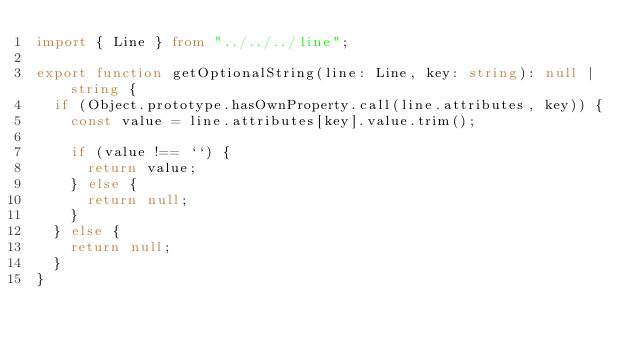<code> <loc_0><loc_0><loc_500><loc_500><_TypeScript_>import { Line } from "../../../line";

export function getOptionalString(line: Line, key: string): null | string {
  if (Object.prototype.hasOwnProperty.call(line.attributes, key)) {
    const value = line.attributes[key].value.trim();

    if (value !== ``) {
      return value;
    } else {
      return null;
    }
  } else {
    return null;
  }
}
</code> 